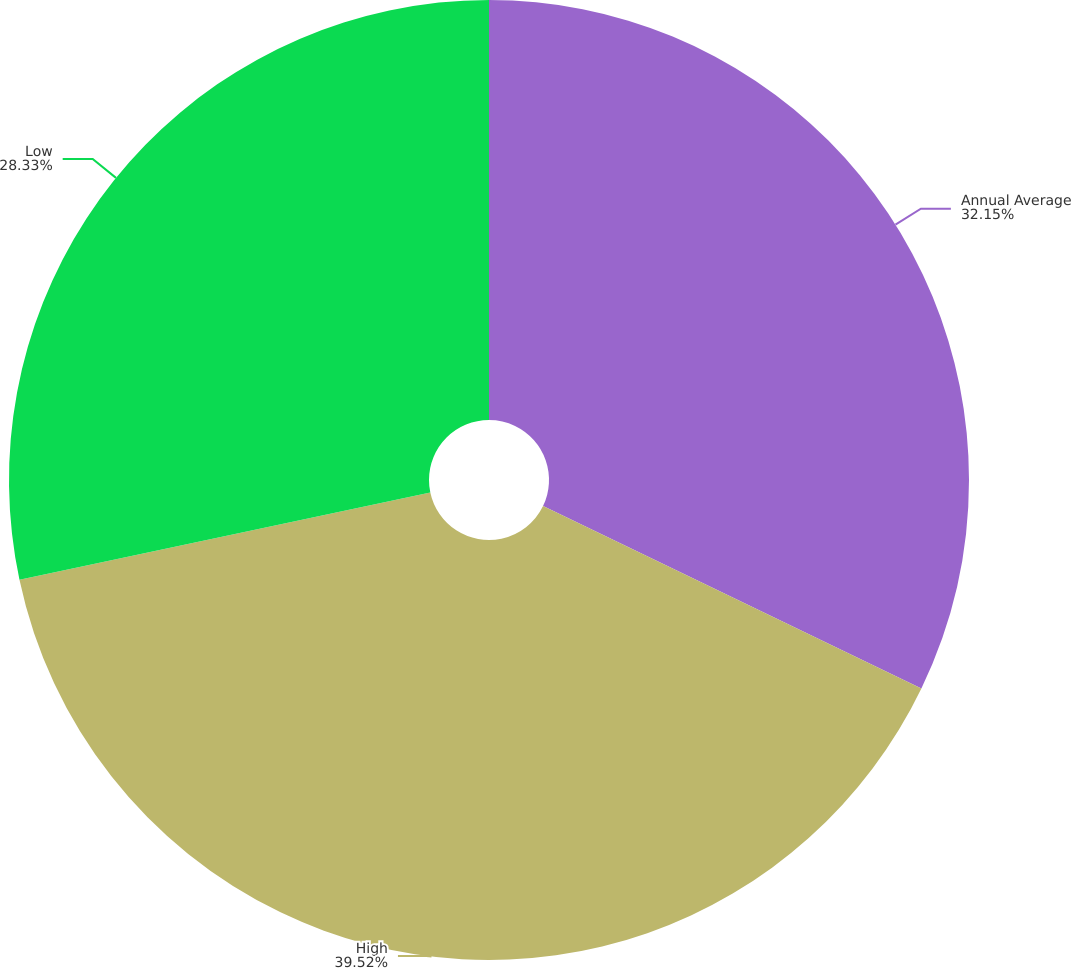Convert chart. <chart><loc_0><loc_0><loc_500><loc_500><pie_chart><fcel>Annual Average<fcel>High<fcel>Low<nl><fcel>32.15%<fcel>39.52%<fcel>28.33%<nl></chart> 